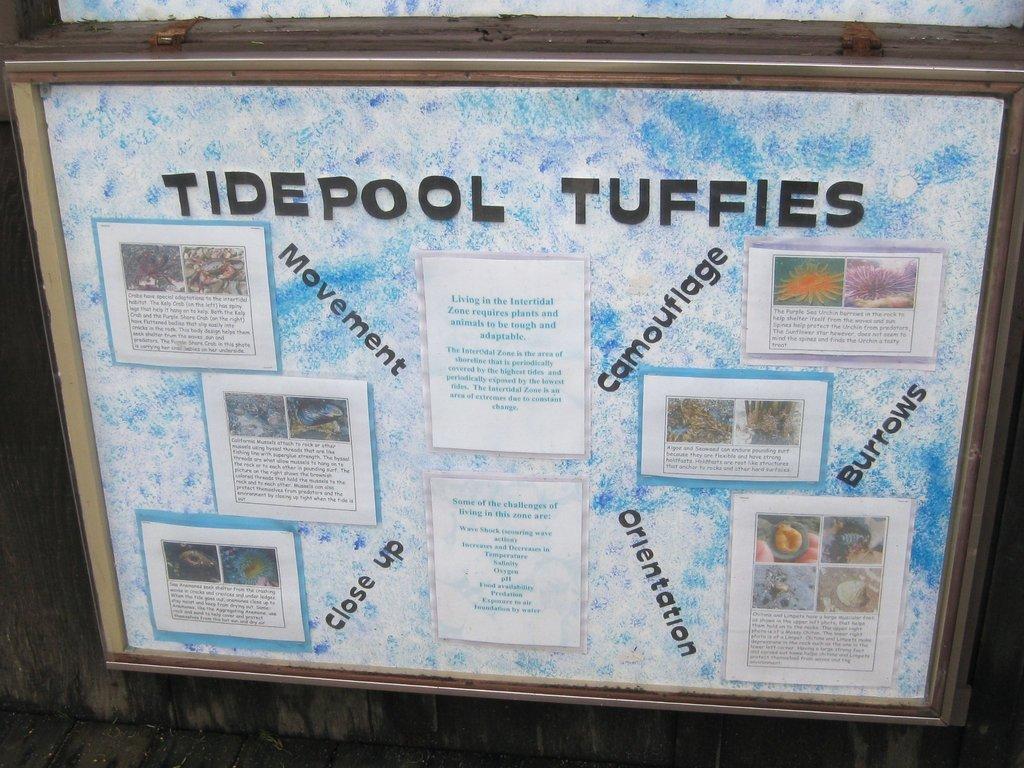What kind of tuffies?
Keep it short and to the point. Tidepool. What do the slanted words say?
Your answer should be compact. Movement, camouflage, close up, orientation, burrows. 